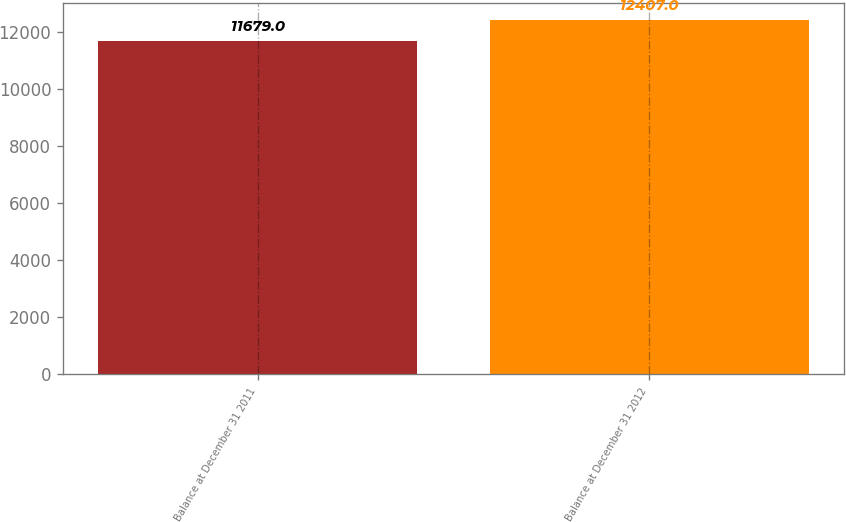<chart> <loc_0><loc_0><loc_500><loc_500><bar_chart><fcel>Balance at December 31 2011<fcel>Balance at December 31 2012<nl><fcel>11679<fcel>12407<nl></chart> 